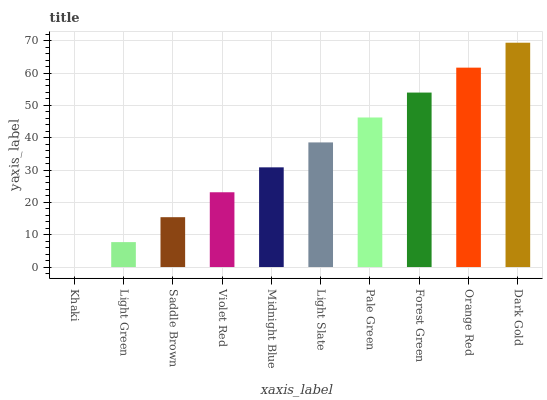Is Khaki the minimum?
Answer yes or no. Yes. Is Dark Gold the maximum?
Answer yes or no. Yes. Is Light Green the minimum?
Answer yes or no. No. Is Light Green the maximum?
Answer yes or no. No. Is Light Green greater than Khaki?
Answer yes or no. Yes. Is Khaki less than Light Green?
Answer yes or no. Yes. Is Khaki greater than Light Green?
Answer yes or no. No. Is Light Green less than Khaki?
Answer yes or no. No. Is Light Slate the high median?
Answer yes or no. Yes. Is Midnight Blue the low median?
Answer yes or no. Yes. Is Orange Red the high median?
Answer yes or no. No. Is Pale Green the low median?
Answer yes or no. No. 